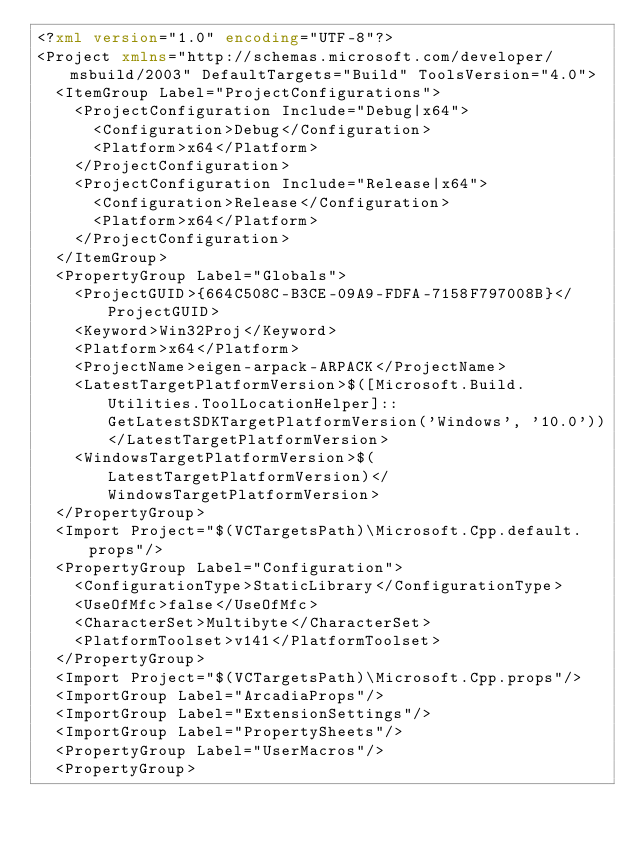Convert code to text. <code><loc_0><loc_0><loc_500><loc_500><_XML_><?xml version="1.0" encoding="UTF-8"?>
<Project xmlns="http://schemas.microsoft.com/developer/msbuild/2003" DefaultTargets="Build" ToolsVersion="4.0">
  <ItemGroup Label="ProjectConfigurations">
    <ProjectConfiguration Include="Debug|x64">
      <Configuration>Debug</Configuration>
      <Platform>x64</Platform>
    </ProjectConfiguration>
    <ProjectConfiguration Include="Release|x64">
      <Configuration>Release</Configuration>
      <Platform>x64</Platform>
    </ProjectConfiguration>
  </ItemGroup>
  <PropertyGroup Label="Globals">
    <ProjectGUID>{664C508C-B3CE-09A9-FDFA-7158F797008B}</ProjectGUID>
    <Keyword>Win32Proj</Keyword>
    <Platform>x64</Platform>
    <ProjectName>eigen-arpack-ARPACK</ProjectName>
    <LatestTargetPlatformVersion>$([Microsoft.Build.Utilities.ToolLocationHelper]::GetLatestSDKTargetPlatformVersion('Windows', '10.0'))</LatestTargetPlatformVersion>
    <WindowsTargetPlatformVersion>$(LatestTargetPlatformVersion)</WindowsTargetPlatformVersion>
  </PropertyGroup>
  <Import Project="$(VCTargetsPath)\Microsoft.Cpp.default.props"/>
  <PropertyGroup Label="Configuration">
    <ConfigurationType>StaticLibrary</ConfigurationType>
    <UseOfMfc>false</UseOfMfc>
    <CharacterSet>Multibyte</CharacterSet>
    <PlatformToolset>v141</PlatformToolset>
  </PropertyGroup>
  <Import Project="$(VCTargetsPath)\Microsoft.Cpp.props"/>
  <ImportGroup Label="ArcadiaProps"/>
  <ImportGroup Label="ExtensionSettings"/>
  <ImportGroup Label="PropertySheets"/>
  <PropertyGroup Label="UserMacros"/>
  <PropertyGroup></code> 